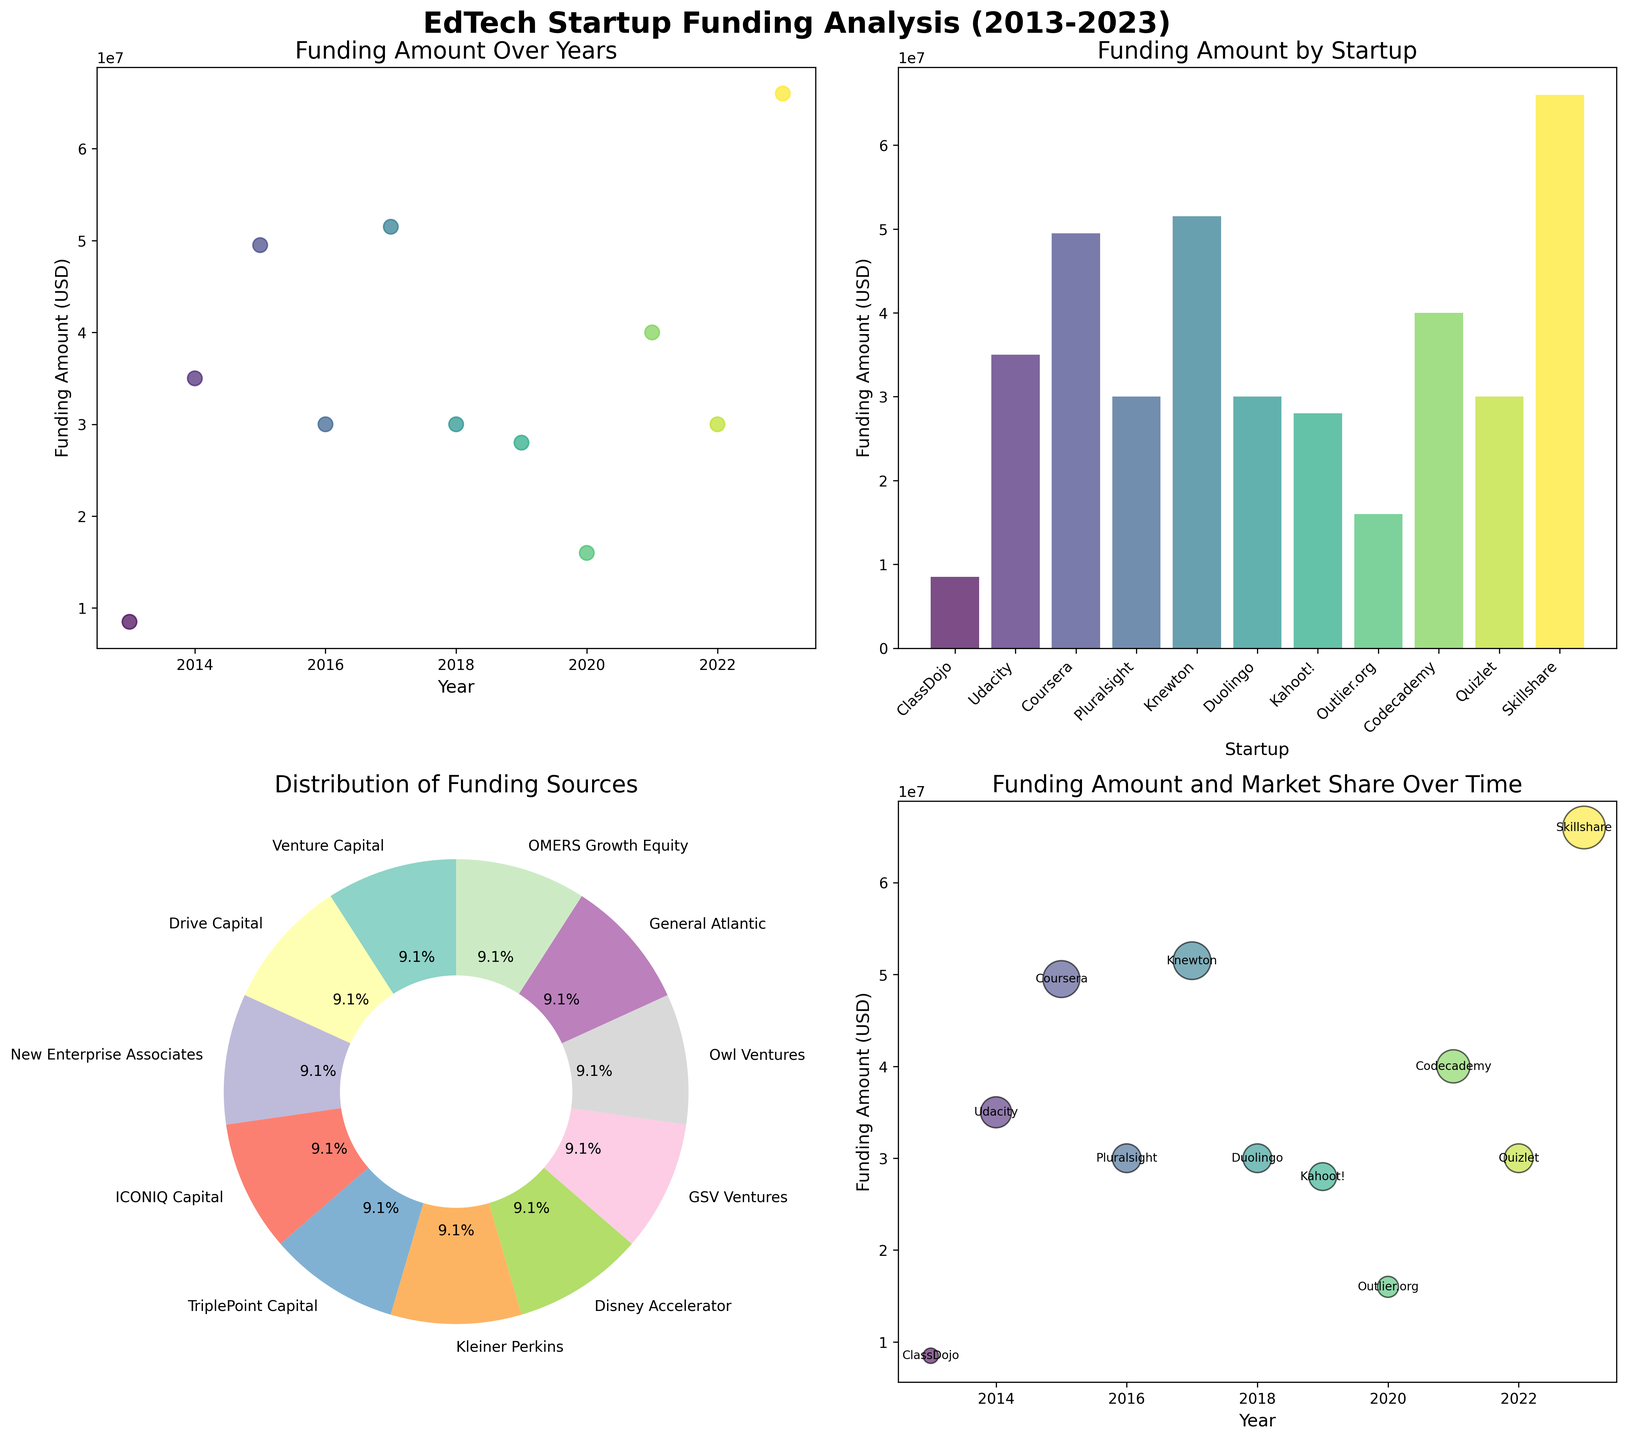What's the main title of the plot? The main title is usually found at the top of the figure. In this plot, it reads "EdTech Startup Funding Analysis (2013-2023)" in bold font.
Answer: EdTech Startup Funding Analysis (2013-2023) Which startup received the highest funding amount? Scan the bar plot titled "Funding Amount by Startup". The tallest bar corresponds to Skillshare, which received $66,000,000.
Answer: Skillshare What is the distribution percentage of funding sources according to the pie chart? Each section of the pie chart is labeled with a funding source and its respective percentage. Analyze the labels and their corresponding sections in the pie chart.
Answer: Each label's percentage, e.g., Venture Capital is X%, Drive Capital is Y%, etc How did the funding amounts evolve over the years? Observing the scatter plot titled "Funding Amount Over Years", look for any trends or patterns in the positioning of the dots over the timeline from 2013 to 2023.
Answer: The funding amounts generally increased over the years What's the combined funding amount of Outlier.org and Duolingo? Look up the bar heights for Outlier.org (2020) and Duolingo (2018) in the "Funding Amount by Startup" bar plot. Outlier.org received $16,000,000, and Duolingo received $30,000,000. Adding them gives $46,000,000.
Answer: $46,000,000 Which year had the highest total funding amount? Refer to the scatter plot "Funding Amount Over Years" and sum the funding amounts for each year. Identify the year with the maximum summed value.
Answer: 2023 What percentage of startups received funding from Venture Capital? Check the pie chart for the portion labeled "Venture Capital" and note its percentage.
Answer: X% (depends on the pie chart sections visible) How does the market share of Codecademy compare to Kahoot!? In the bubble plot "Funding Amount and Market Share Over Time", compare the size of the bubbles representing Codecademy (2021) and Kahoot! (2019). Codecademy has a larger market share as its bubble is bigger.
Answer: Codecademy > Kahoot! Did any startup receive repeated funding from the same source? Use the labels of startups and funding sources in the dataset and check if any funding source appears more than once for different years.
Answer: No Is there a clear trend in the funding sources over the years? Refer to both the scatter plot and the pie chart, identifying any patterns or changes in the variety of funding sources over time.
Answer: No clear trend 